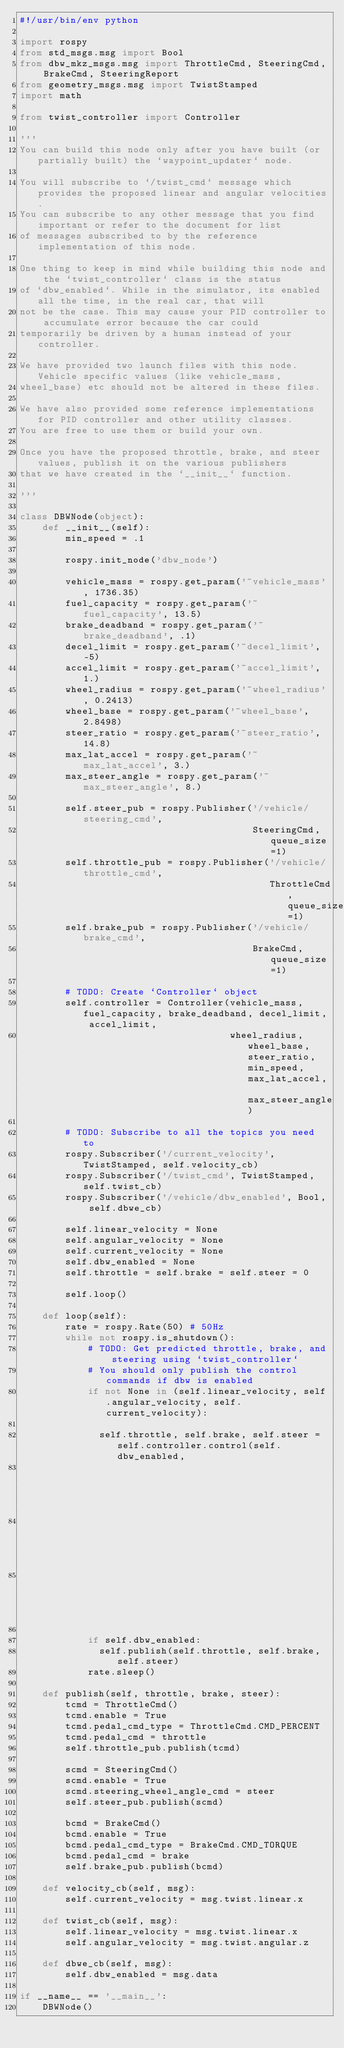Convert code to text. <code><loc_0><loc_0><loc_500><loc_500><_Python_>#!/usr/bin/env python

import rospy
from std_msgs.msg import Bool
from dbw_mkz_msgs.msg import ThrottleCmd, SteeringCmd, BrakeCmd, SteeringReport
from geometry_msgs.msg import TwistStamped
import math

from twist_controller import Controller

'''
You can build this node only after you have built (or partially built) the `waypoint_updater` node.

You will subscribe to `/twist_cmd` message which provides the proposed linear and angular velocities.
You can subscribe to any other message that you find important or refer to the document for list
of messages subscribed to by the reference implementation of this node.

One thing to keep in mind while building this node and the `twist_controller` class is the status
of `dbw_enabled`. While in the simulator, its enabled all the time, in the real car, that will
not be the case. This may cause your PID controller to accumulate error because the car could
temporarily be driven by a human instead of your controller.

We have provided two launch files with this node. Vehicle specific values (like vehicle_mass,
wheel_base) etc should not be altered in these files.

We have also provided some reference implementations for PID controller and other utility classes.
You are free to use them or build your own.

Once you have the proposed throttle, brake, and steer values, publish it on the various publishers
that we have created in the `__init__` function.

'''

class DBWNode(object):
    def __init__(self):
        min_speed = .1

        rospy.init_node('dbw_node')

        vehicle_mass = rospy.get_param('~vehicle_mass', 1736.35)
        fuel_capacity = rospy.get_param('~fuel_capacity', 13.5)
        brake_deadband = rospy.get_param('~brake_deadband', .1)
        decel_limit = rospy.get_param('~decel_limit', -5)
        accel_limit = rospy.get_param('~accel_limit', 1.)
        wheel_radius = rospy.get_param('~wheel_radius', 0.2413)
        wheel_base = rospy.get_param('~wheel_base', 2.8498)
        steer_ratio = rospy.get_param('~steer_ratio', 14.8)
        max_lat_accel = rospy.get_param('~max_lat_accel', 3.)
        max_steer_angle = rospy.get_param('~max_steer_angle', 8.)

        self.steer_pub = rospy.Publisher('/vehicle/steering_cmd',
                                         SteeringCmd, queue_size=1)
        self.throttle_pub = rospy.Publisher('/vehicle/throttle_cmd',
                                            ThrottleCmd, queue_size=1)
        self.brake_pub = rospy.Publisher('/vehicle/brake_cmd',
                                         BrakeCmd, queue_size=1)

        # TODO: Create `Controller` object
        self.controller = Controller(vehicle_mass, fuel_capacity, brake_deadband, decel_limit, accel_limit, 
                                     wheel_radius, wheel_base, steer_ratio, min_speed, max_lat_accel, max_steer_angle)

        # TODO: Subscribe to all the topics you need to
        rospy.Subscriber('/current_velocity', TwistStamped, self.velocity_cb)
        rospy.Subscriber('/twist_cmd', TwistStamped, self.twist_cb)
        rospy.Subscriber('/vehicle/dbw_enabled', Bool, self.dbwe_cb)

        self.linear_velocity = None
        self.angular_velocity = None
        self.current_velocity = None
        self.dbw_enabled = None
        self.throttle = self.brake = self.steer = 0

        self.loop()

    def loop(self):
        rate = rospy.Rate(50) # 50Hz
        while not rospy.is_shutdown():
            # TODO: Get predicted throttle, brake, and steering using `twist_controller`
            # You should only publish the control commands if dbw is enabled
            if not None in (self.linear_velocity, self.angular_velocity, self.current_velocity):

              self.throttle, self.brake, self.steer = self.controller.control(self.dbw_enabled,
                                                                              self.linear_velocity,
                                                                              self.angular_velocity,
                                                                              self.current_velocity)

            if self.dbw_enabled:
              self.publish(self.throttle, self.brake, self.steer)
            rate.sleep()

    def publish(self, throttle, brake, steer):
        tcmd = ThrottleCmd()
        tcmd.enable = True
        tcmd.pedal_cmd_type = ThrottleCmd.CMD_PERCENT
        tcmd.pedal_cmd = throttle
        self.throttle_pub.publish(tcmd)

        scmd = SteeringCmd()
        scmd.enable = True
        scmd.steering_wheel_angle_cmd = steer
        self.steer_pub.publish(scmd)

        bcmd = BrakeCmd()
        bcmd.enable = True
        bcmd.pedal_cmd_type = BrakeCmd.CMD_TORQUE
        bcmd.pedal_cmd = brake
        self.brake_pub.publish(bcmd)

    def velocity_cb(self, msg):
        self.current_velocity = msg.twist.linear.x

    def twist_cb(self, msg):
        self.linear_velocity = msg.twist.linear.x
        self.angular_velocity = msg.twist.angular.z

    def dbwe_cb(self, msg):
        self.dbw_enabled = msg.data

if __name__ == '__main__':
    DBWNode()
</code> 